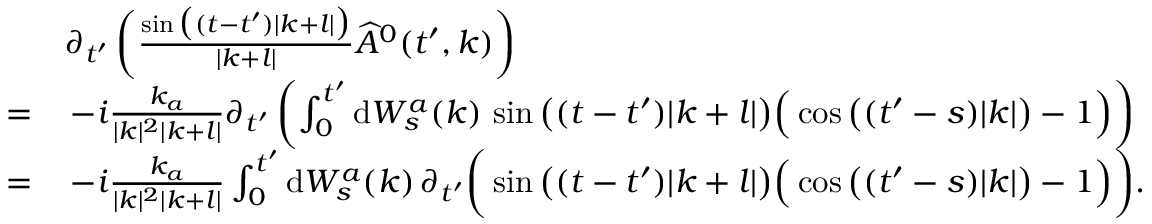<formula> <loc_0><loc_0><loc_500><loc_500>\begin{array} { r l } & { \partial _ { t ^ { \prime } } \left ( \frac { \sin \left ( ( t - t ^ { \prime } ) | k + l | \right ) } { | k + l | } \widehat { A } ^ { 0 } ( t ^ { \prime } , k ) \right ) } \\ { = } & { \, - i \frac { k _ { a } } { | k | ^ { 2 } | k + l | } \partial _ { t ^ { \prime } } \left ( \int _ { 0 } ^ { t ^ { \prime } } d W _ { s } ^ { a } ( k ) \, \sin \left ( ( t - t ^ { \prime } ) | k + l | \right ) \left ( \cos \left ( ( t ^ { \prime } - s ) | k | \right ) - 1 \right ) \right ) } \\ { = } & { \, - i \frac { k _ { a } } { | k | ^ { 2 } | k + l | } \int _ { 0 } ^ { t ^ { \prime } } d W _ { s } ^ { a } ( k ) \, \partial _ { t ^ { \prime } } \left ( \sin \left ( ( t - t ^ { \prime } ) | k + l | \right ) \left ( \cos \left ( ( t ^ { \prime } - s ) | k | \right ) - 1 \right ) \right ) . } \end{array}</formula> 